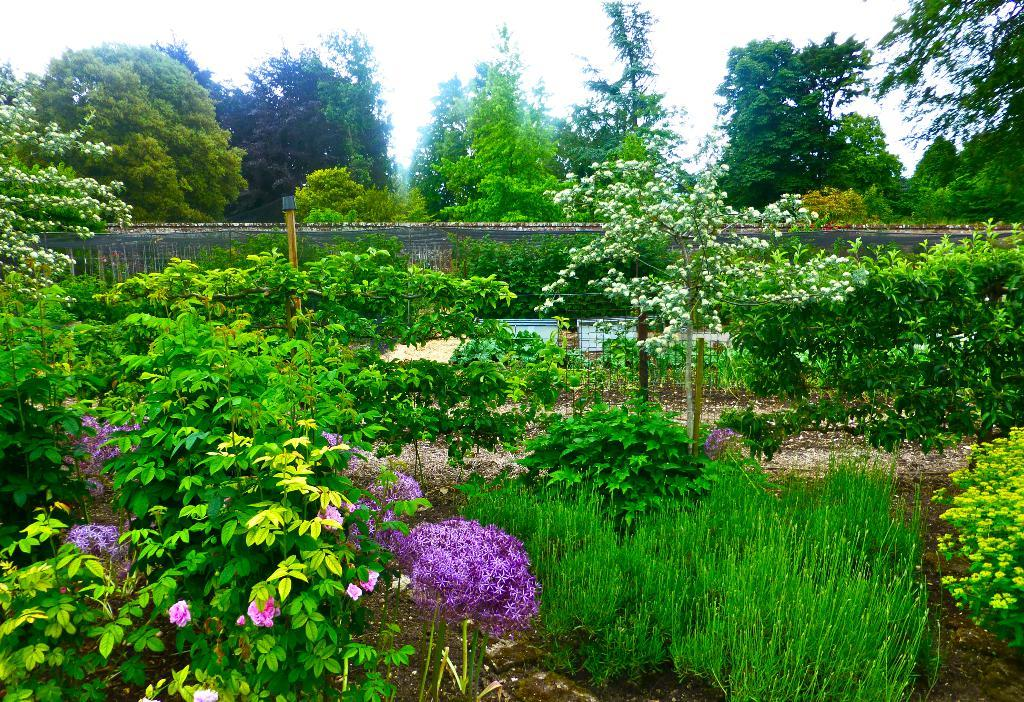What type of structure can be seen in the image? There is a wall in the image. What else is present in the image besides the wall? There is a pole, trees, plants, a mesh, boards, and flowers visible in the image. Can you describe the vegetation in the image? There are trees and plants in the image, as well as flowers. What is visible in the background of the image? The sky is visible in the image. Reasoning: Let's think step by step by step in order to produce the conversation. We start by identifying the main structure in the image, which is the wall. Then, we expand the conversation to include other objects and elements that are also visible, such as the pole, trees, plants, mesh, boards, and flowers. Each question is designed to elicit a specific detail about the image that is known from the provided facts. Absurd Question/Answer: What type of insurance policy is being discussed by the brothers in the image? There are no people, let alone brothers, present in the image, and therefore no discussion about insurance policies can be observed. What type of copper wire is being used to connect the brothers' devices in the image? There are no people, let alone brothers, present in the image, and therefore no copper wire connecting devices can be observed. 